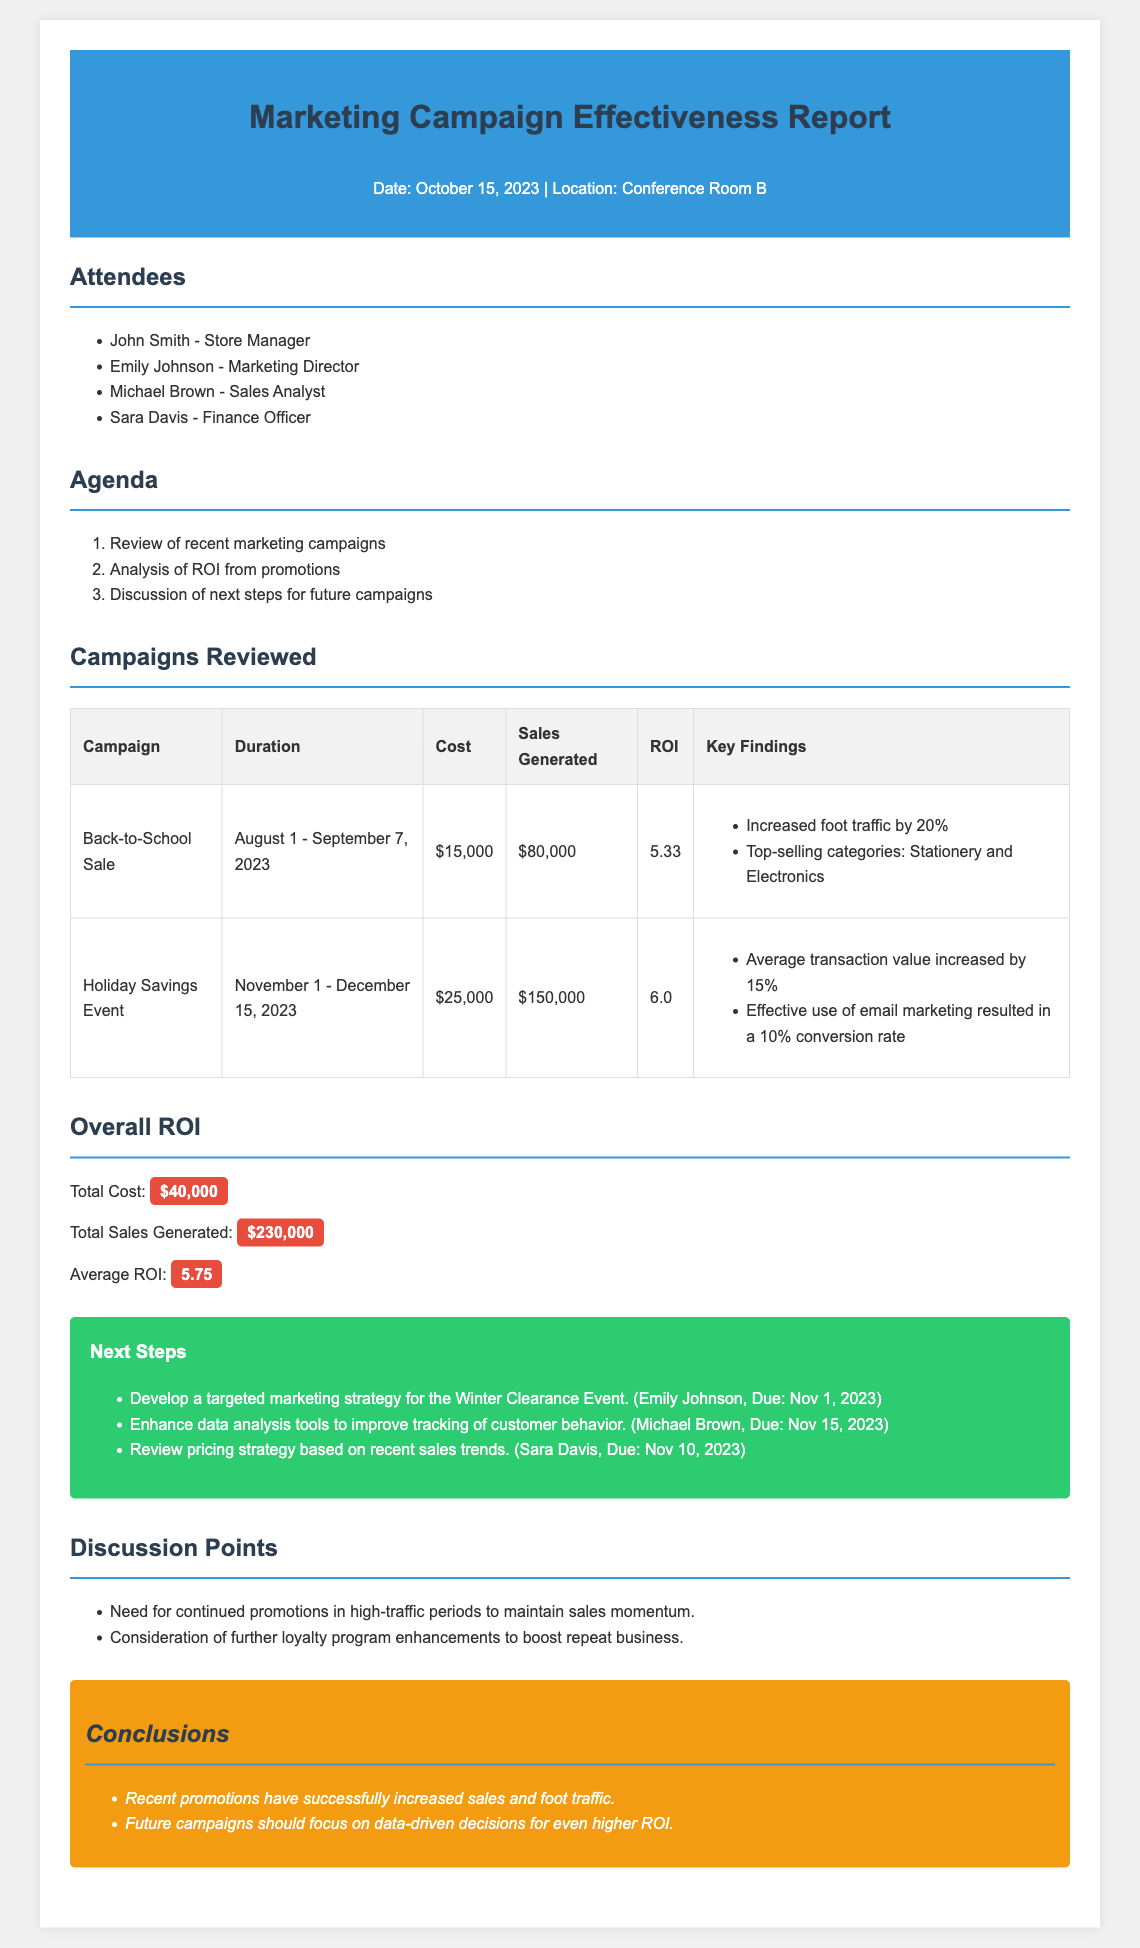What was the total cost of the campaigns reviewed? The total cost is mentioned in the "Overall ROI" section as the sum of campaign costs: $15,000 + $25,000 = $40,000.
Answer: $40,000 What were the top-selling categories during the Back-to-School Sale? Key findings of the Back-to-School Sale campaign specify the top-selling categories.
Answer: Stationery and Electronics What is the average ROI of the campaigns? The average ROI is given in the "Overall ROI" section, which is calculated from the total sales generated divided by the total cost.
Answer: 5.75 Who is responsible for developing the marketing strategy for the Winter Clearance Event? The "Next Steps" section lists Emily Johnson as responsible for this task.
Answer: Emily Johnson What increased the average transaction value during the Holiday Savings Event? The key findings state that the average transaction value increased by 15% as a direct result of the event.
Answer: 15% What were the dates of the Holiday Savings Event? The duration of the Holiday Savings Event is outlined in the "Campaigns Reviewed" section.
Answer: November 1 - December 15, 2023 What is one suggested future campaign strategy? The document discusses the need for continued promotions during high-traffic periods to maintain sales momentum.
Answer: Continued promotions in high-traffic periods What was the total sales generated from the campaigns? The total sales generated is summarized in the "Overall ROI" section as the cumulative result of both campaigns.
Answer: $230,000 What is the conclusion regarding future campaigns? The concluding statements identify the focus of future campaigns should be on making data-driven decisions for better ROI.
Answer: Data-driven decisions for higher ROI 